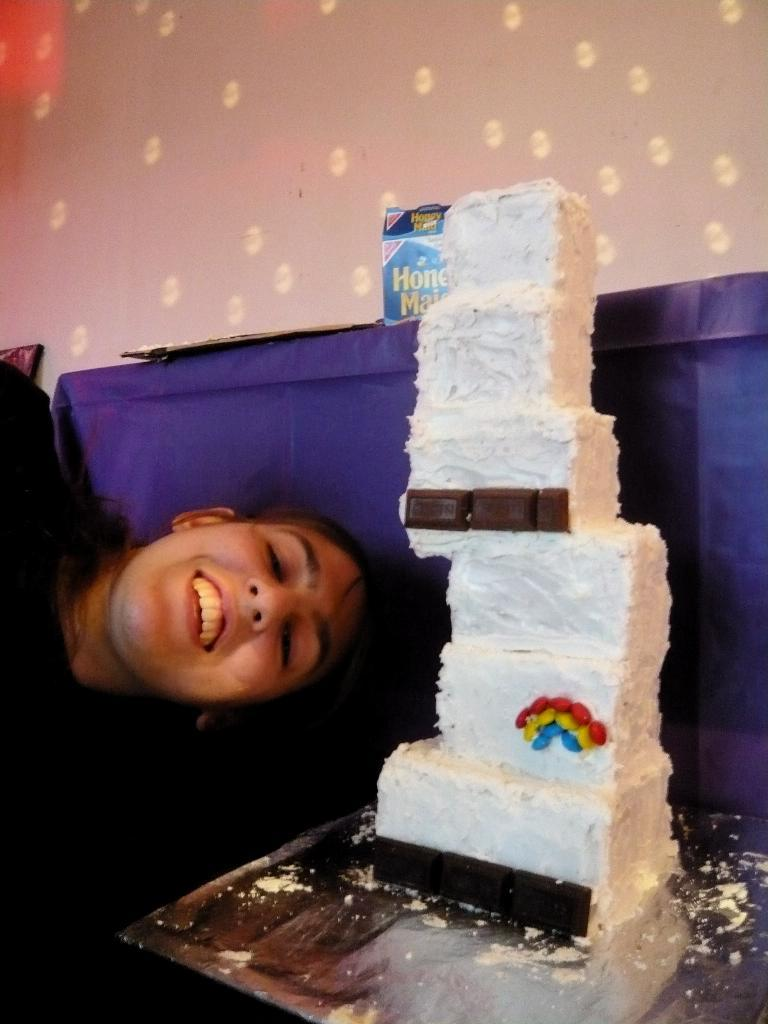Who or what is present in the image? There is a person in the image. What is on the table in the image? There is a cake on a table in the image. What color is the surface behind the cake? The surface behind the cake is purple. What can be seen in the background of the image? There is a wall in the background of the image. What type of anger can be seen on the person's face in the image? There is no indication of anger on the person's face in the image. How does the heat affect the cake in the image? The image does not provide any information about the temperature or heat affecting the cake. 